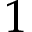Convert formula to latex. <formula><loc_0><loc_0><loc_500><loc_500>1</formula> 